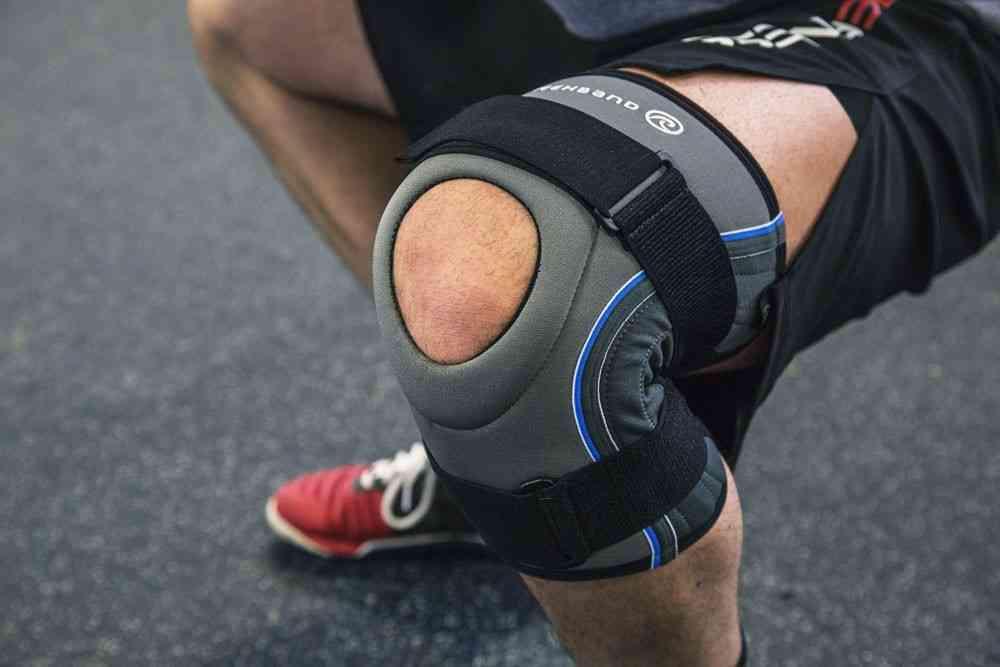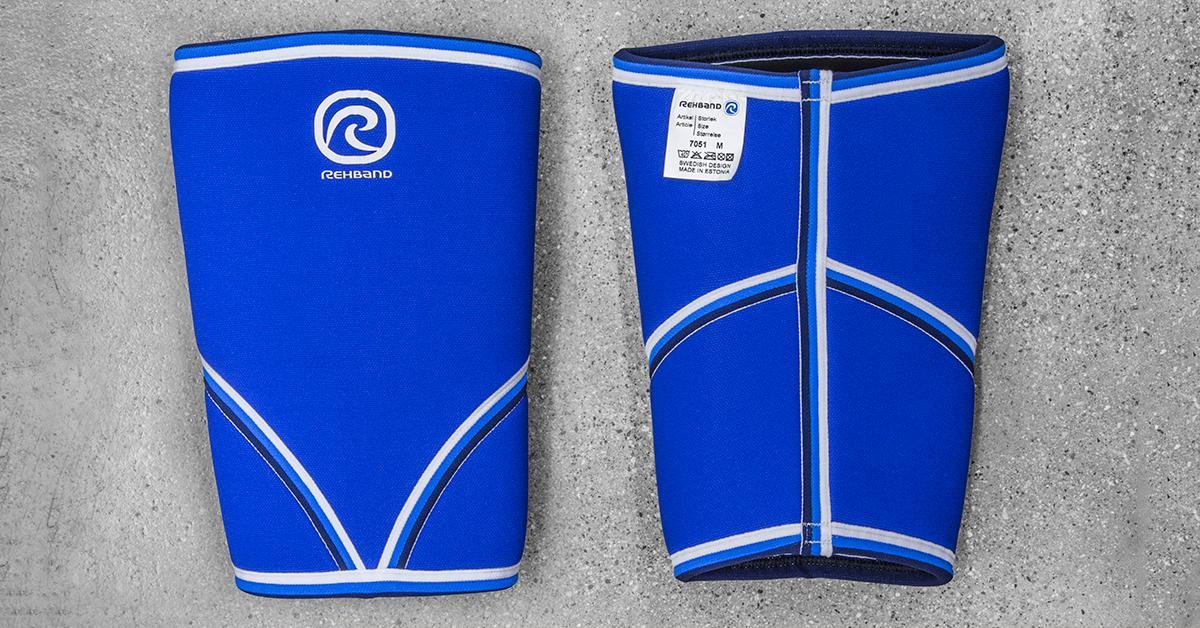The first image is the image on the left, the second image is the image on the right. Given the left and right images, does the statement "No one is wearing the pads in the image on the right." hold true? Answer yes or no. Yes. 